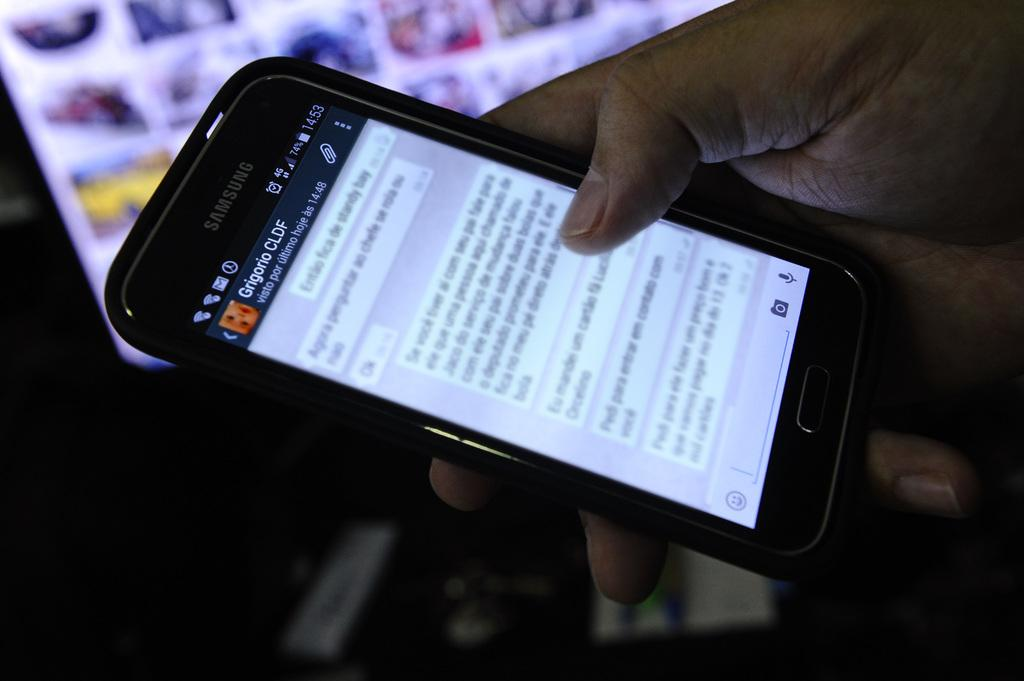Provide a one-sentence caption for the provided image. a phone that has CLDF written on it. 